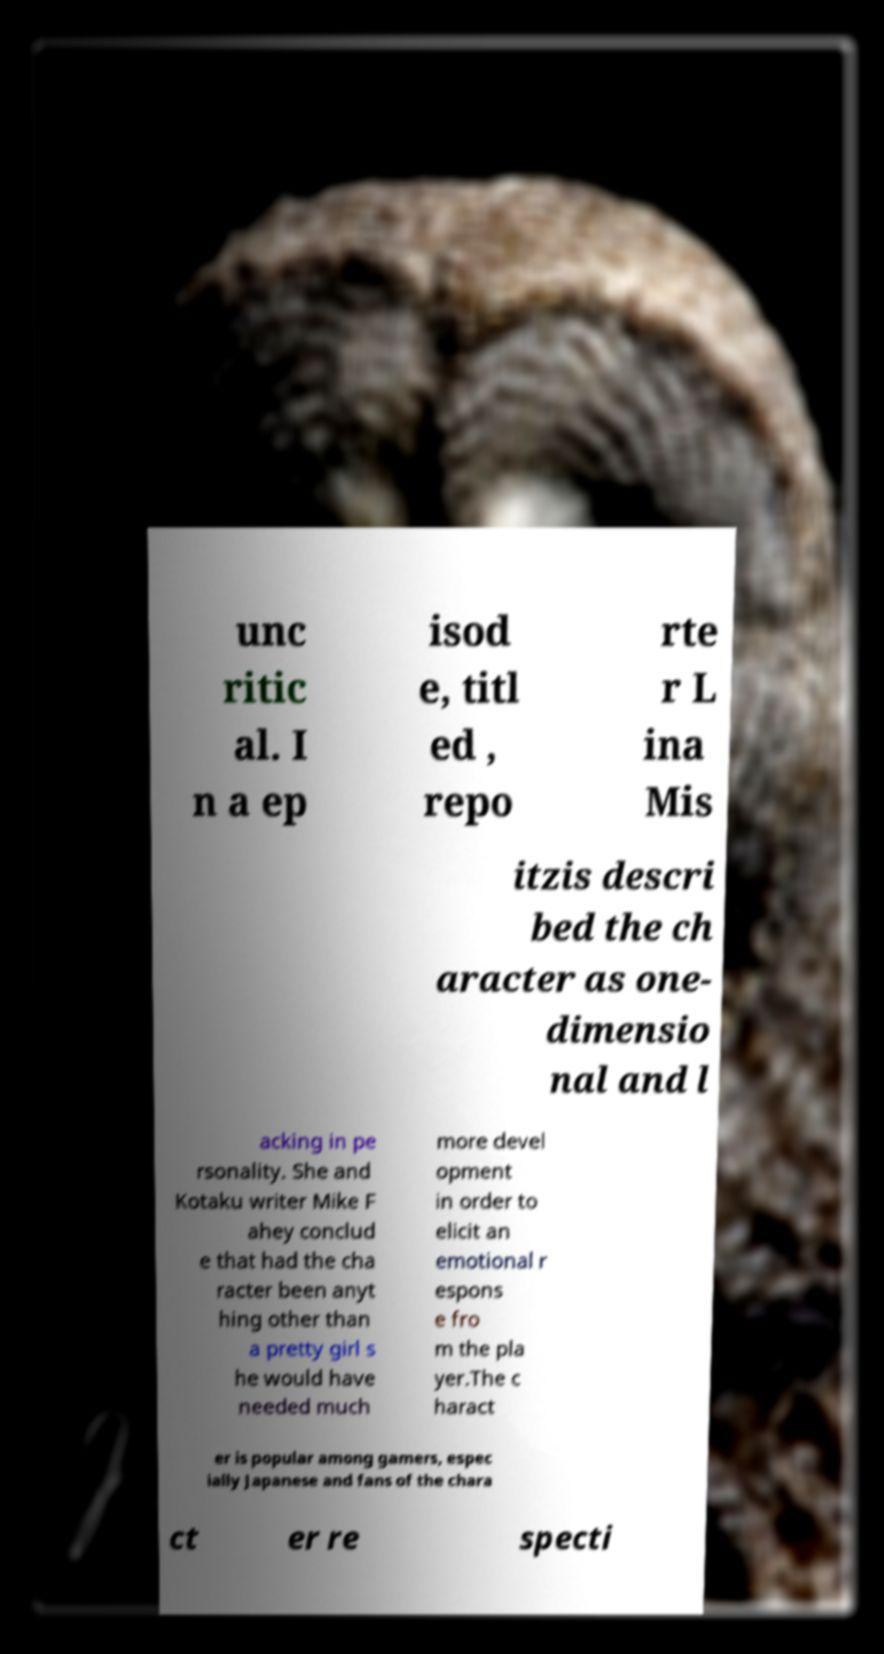I need the written content from this picture converted into text. Can you do that? unc ritic al. I n a ep isod e, titl ed , repo rte r L ina Mis itzis descri bed the ch aracter as one- dimensio nal and l acking in pe rsonality. She and Kotaku writer Mike F ahey conclud e that had the cha racter been anyt hing other than a pretty girl s he would have needed much more devel opment in order to elicit an emotional r espons e fro m the pla yer.The c haract er is popular among gamers, espec ially Japanese and fans of the chara ct er re specti 